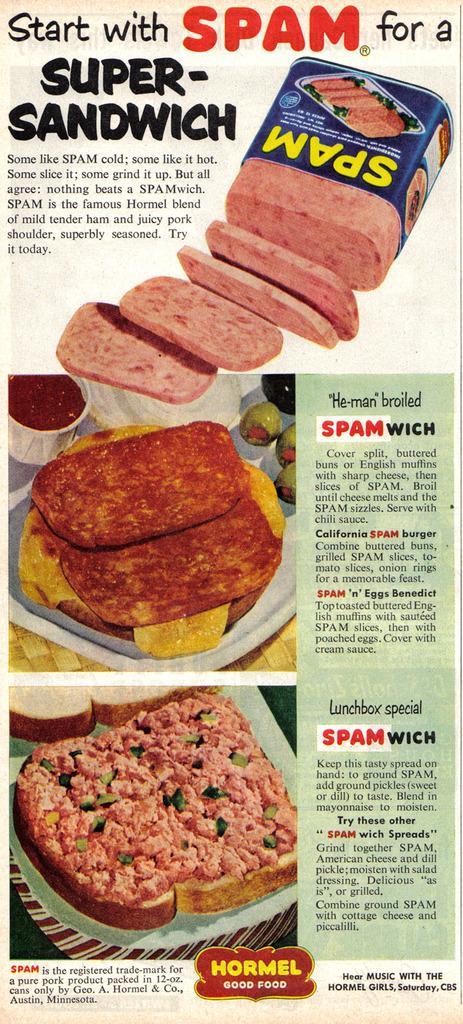Please provide a concise description of this image. In the center of the image we can see one poster. On the poster, we can see plates, one bowl, some food items, some text and a few other objects. 